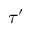Convert formula to latex. <formula><loc_0><loc_0><loc_500><loc_500>\tau ^ { \prime }</formula> 